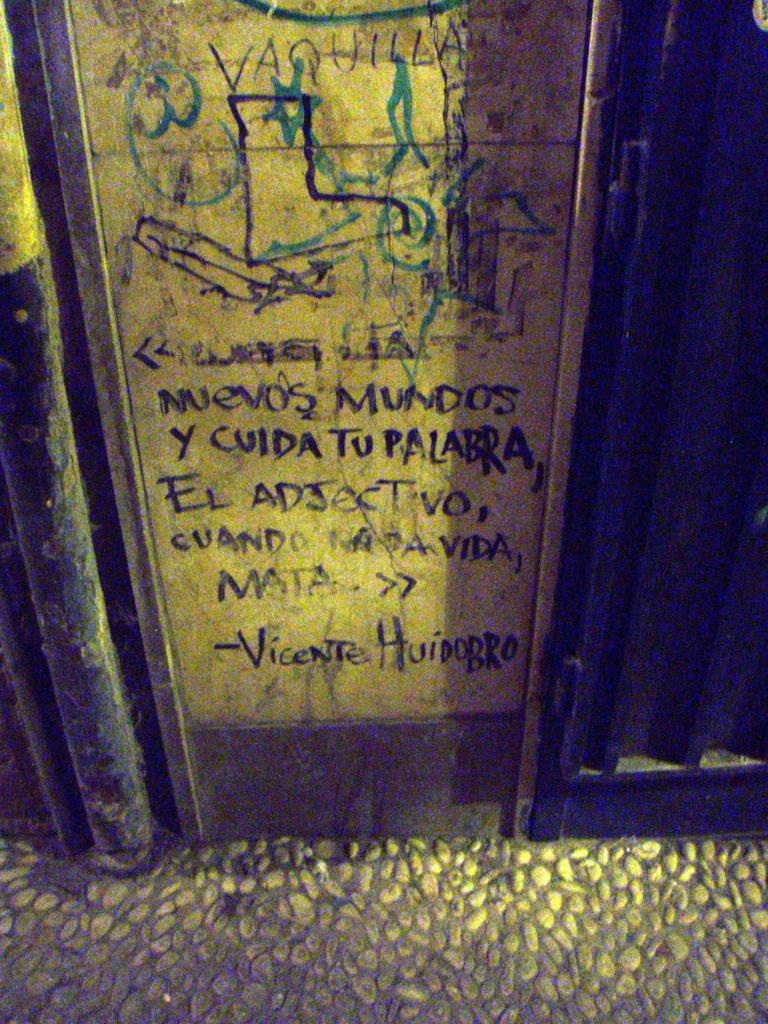What is the main object in the image? There is a board in the image. What can be seen on the floor in the image? The floor in the image has pebbles. What type of wrist accessory is visible on the board in the image? There is no wrist accessory present on the board in the image. What kind of straw is used to drink from the vessel in the image? There is no vessel or straw present in the image. 